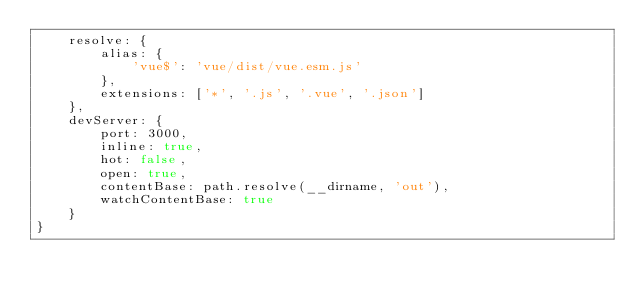Convert code to text. <code><loc_0><loc_0><loc_500><loc_500><_JavaScript_>    resolve: {
        alias: {
            'vue$': 'vue/dist/vue.esm.js'
        },
        extensions: ['*', '.js', '.vue', '.json']
    },
    devServer: {
        port: 3000,
        inline: true,
        hot: false,
        open: true,
        contentBase: path.resolve(__dirname, 'out'),
        watchContentBase: true
    }
}</code> 